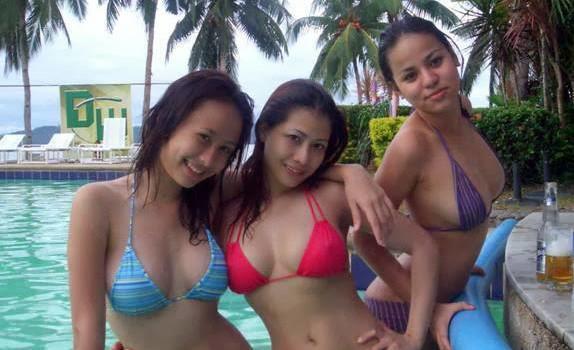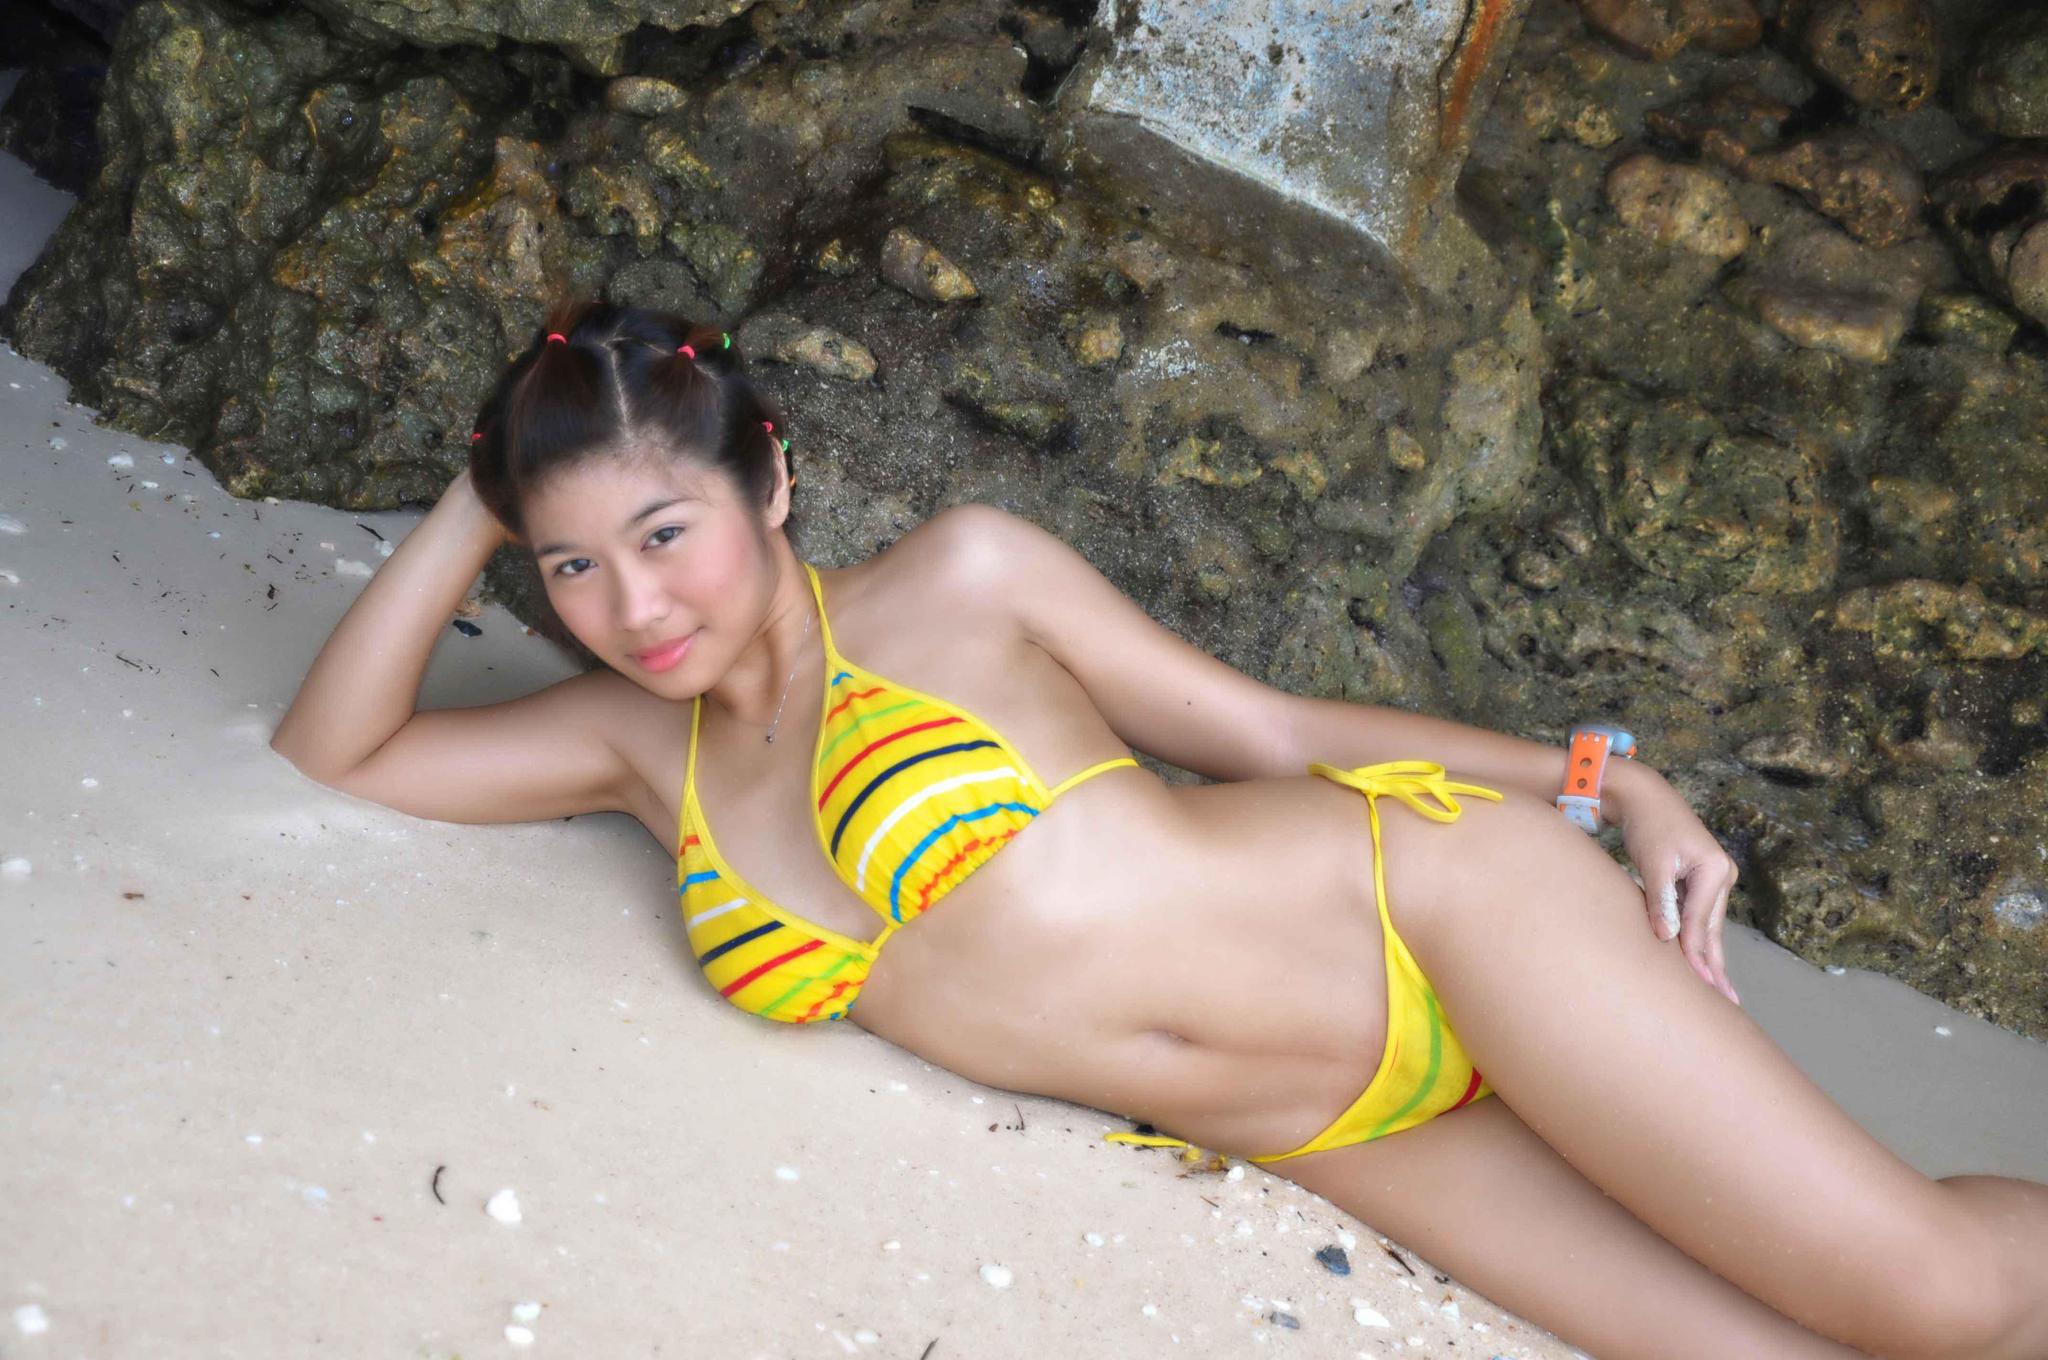The first image is the image on the left, the second image is the image on the right. Given the left and right images, does the statement "The combined images contain four bikini models, and none have sunglasses covering their eyes." hold true? Answer yes or no. Yes. 